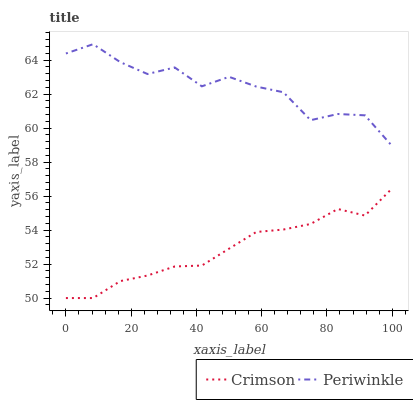Does Crimson have the minimum area under the curve?
Answer yes or no. Yes. Does Periwinkle have the maximum area under the curve?
Answer yes or no. Yes. Does Periwinkle have the minimum area under the curve?
Answer yes or no. No. Is Crimson the smoothest?
Answer yes or no. Yes. Is Periwinkle the roughest?
Answer yes or no. Yes. Is Periwinkle the smoothest?
Answer yes or no. No. Does Crimson have the lowest value?
Answer yes or no. Yes. Does Periwinkle have the lowest value?
Answer yes or no. No. Does Periwinkle have the highest value?
Answer yes or no. Yes. Is Crimson less than Periwinkle?
Answer yes or no. Yes. Is Periwinkle greater than Crimson?
Answer yes or no. Yes. Does Crimson intersect Periwinkle?
Answer yes or no. No. 